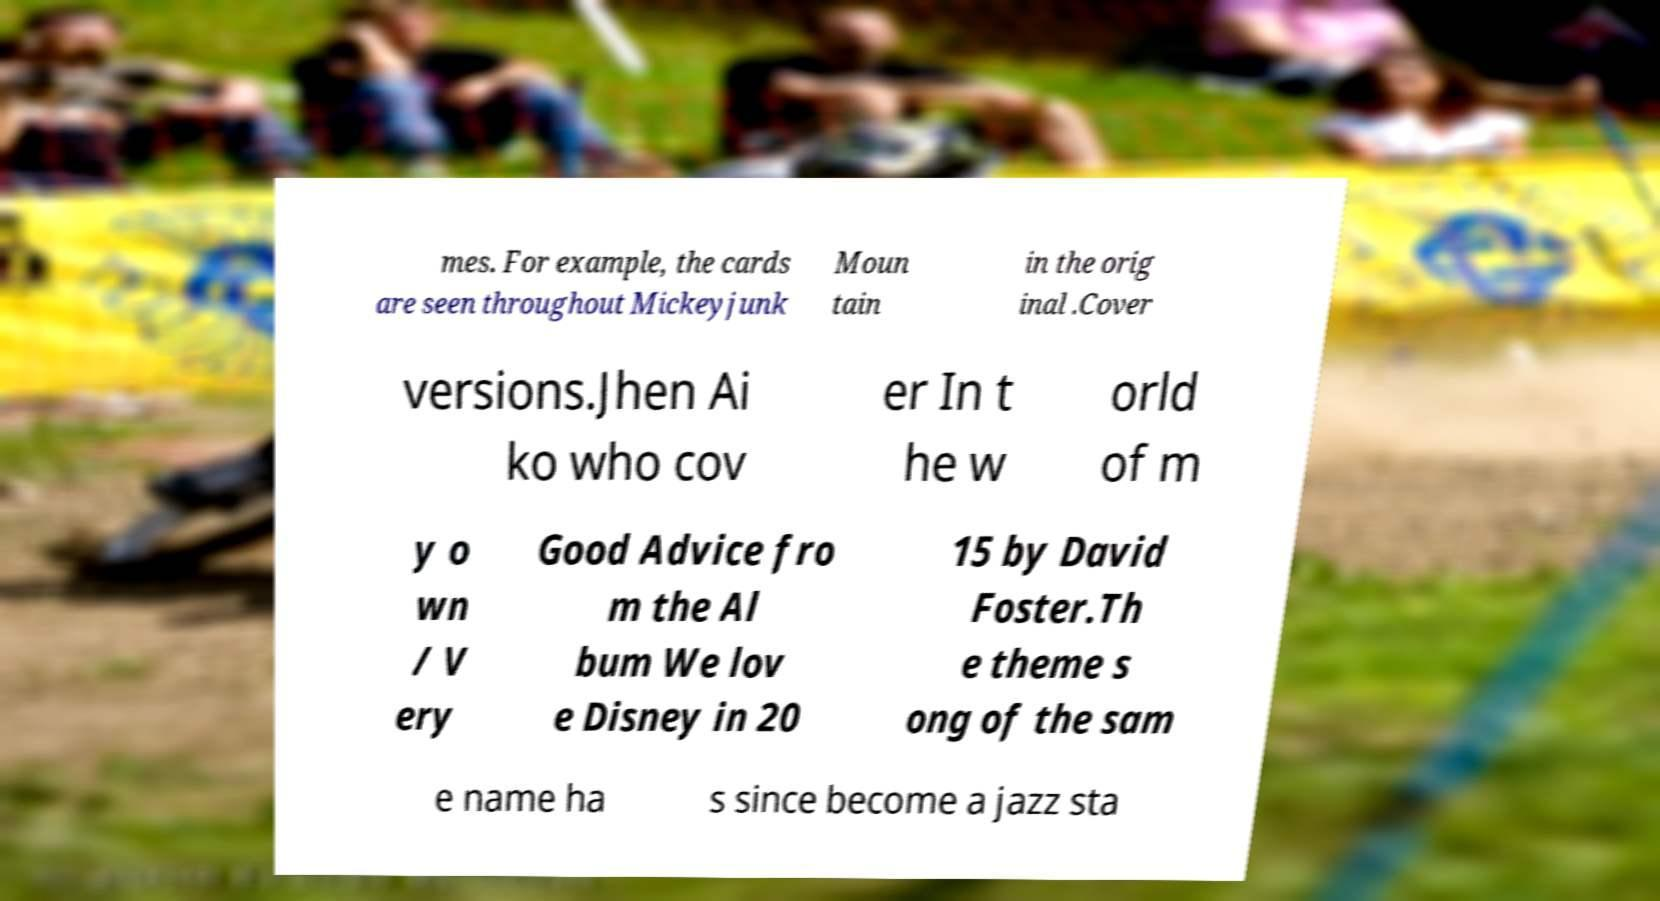Can you read and provide the text displayed in the image?This photo seems to have some interesting text. Can you extract and type it out for me? mes. For example, the cards are seen throughout Mickeyjunk Moun tain in the orig inal .Cover versions.Jhen Ai ko who cov er In t he w orld of m y o wn / V ery Good Advice fro m the Al bum We lov e Disney in 20 15 by David Foster.Th e theme s ong of the sam e name ha s since become a jazz sta 